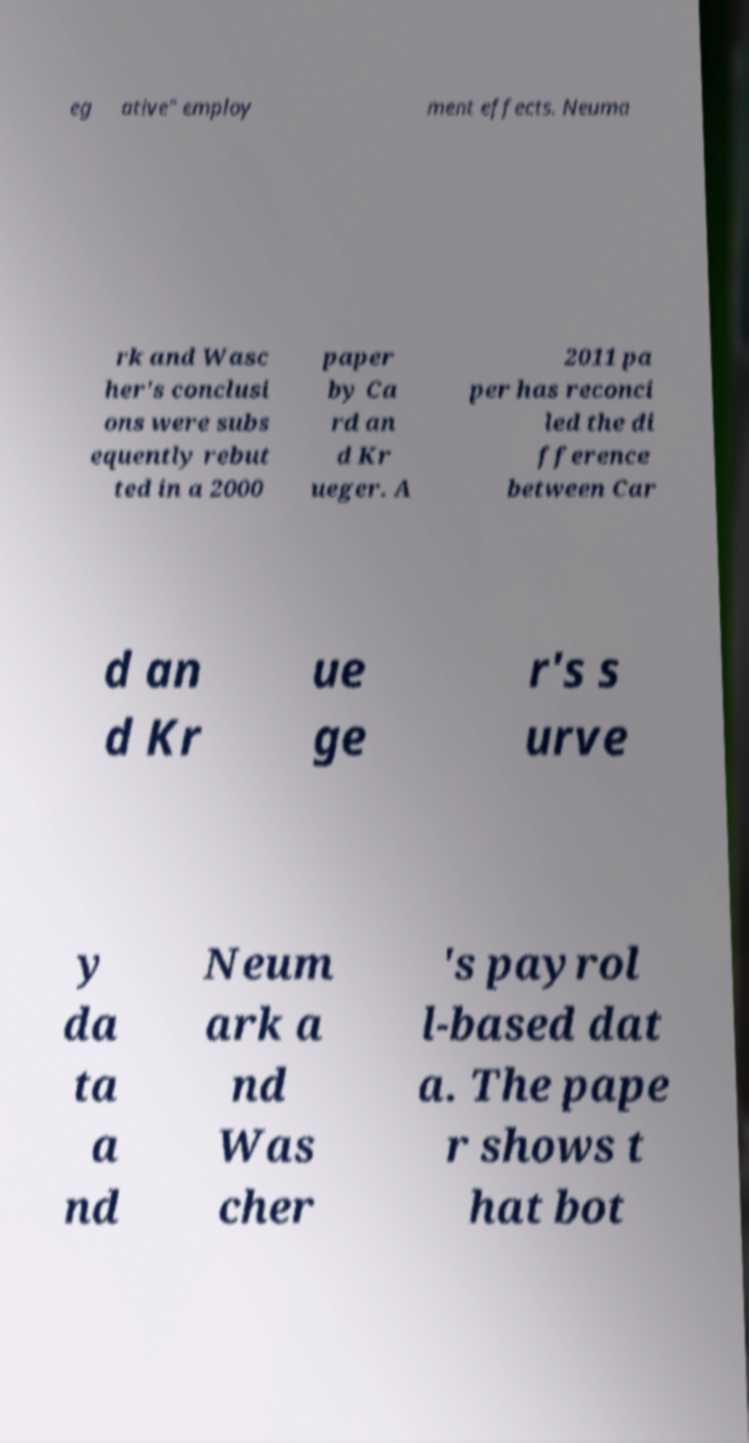Please read and relay the text visible in this image. What does it say? eg ative" employ ment effects. Neuma rk and Wasc her's conclusi ons were subs equently rebut ted in a 2000 paper by Ca rd an d Kr ueger. A 2011 pa per has reconci led the di fference between Car d an d Kr ue ge r's s urve y da ta a nd Neum ark a nd Was cher 's payrol l-based dat a. The pape r shows t hat bot 